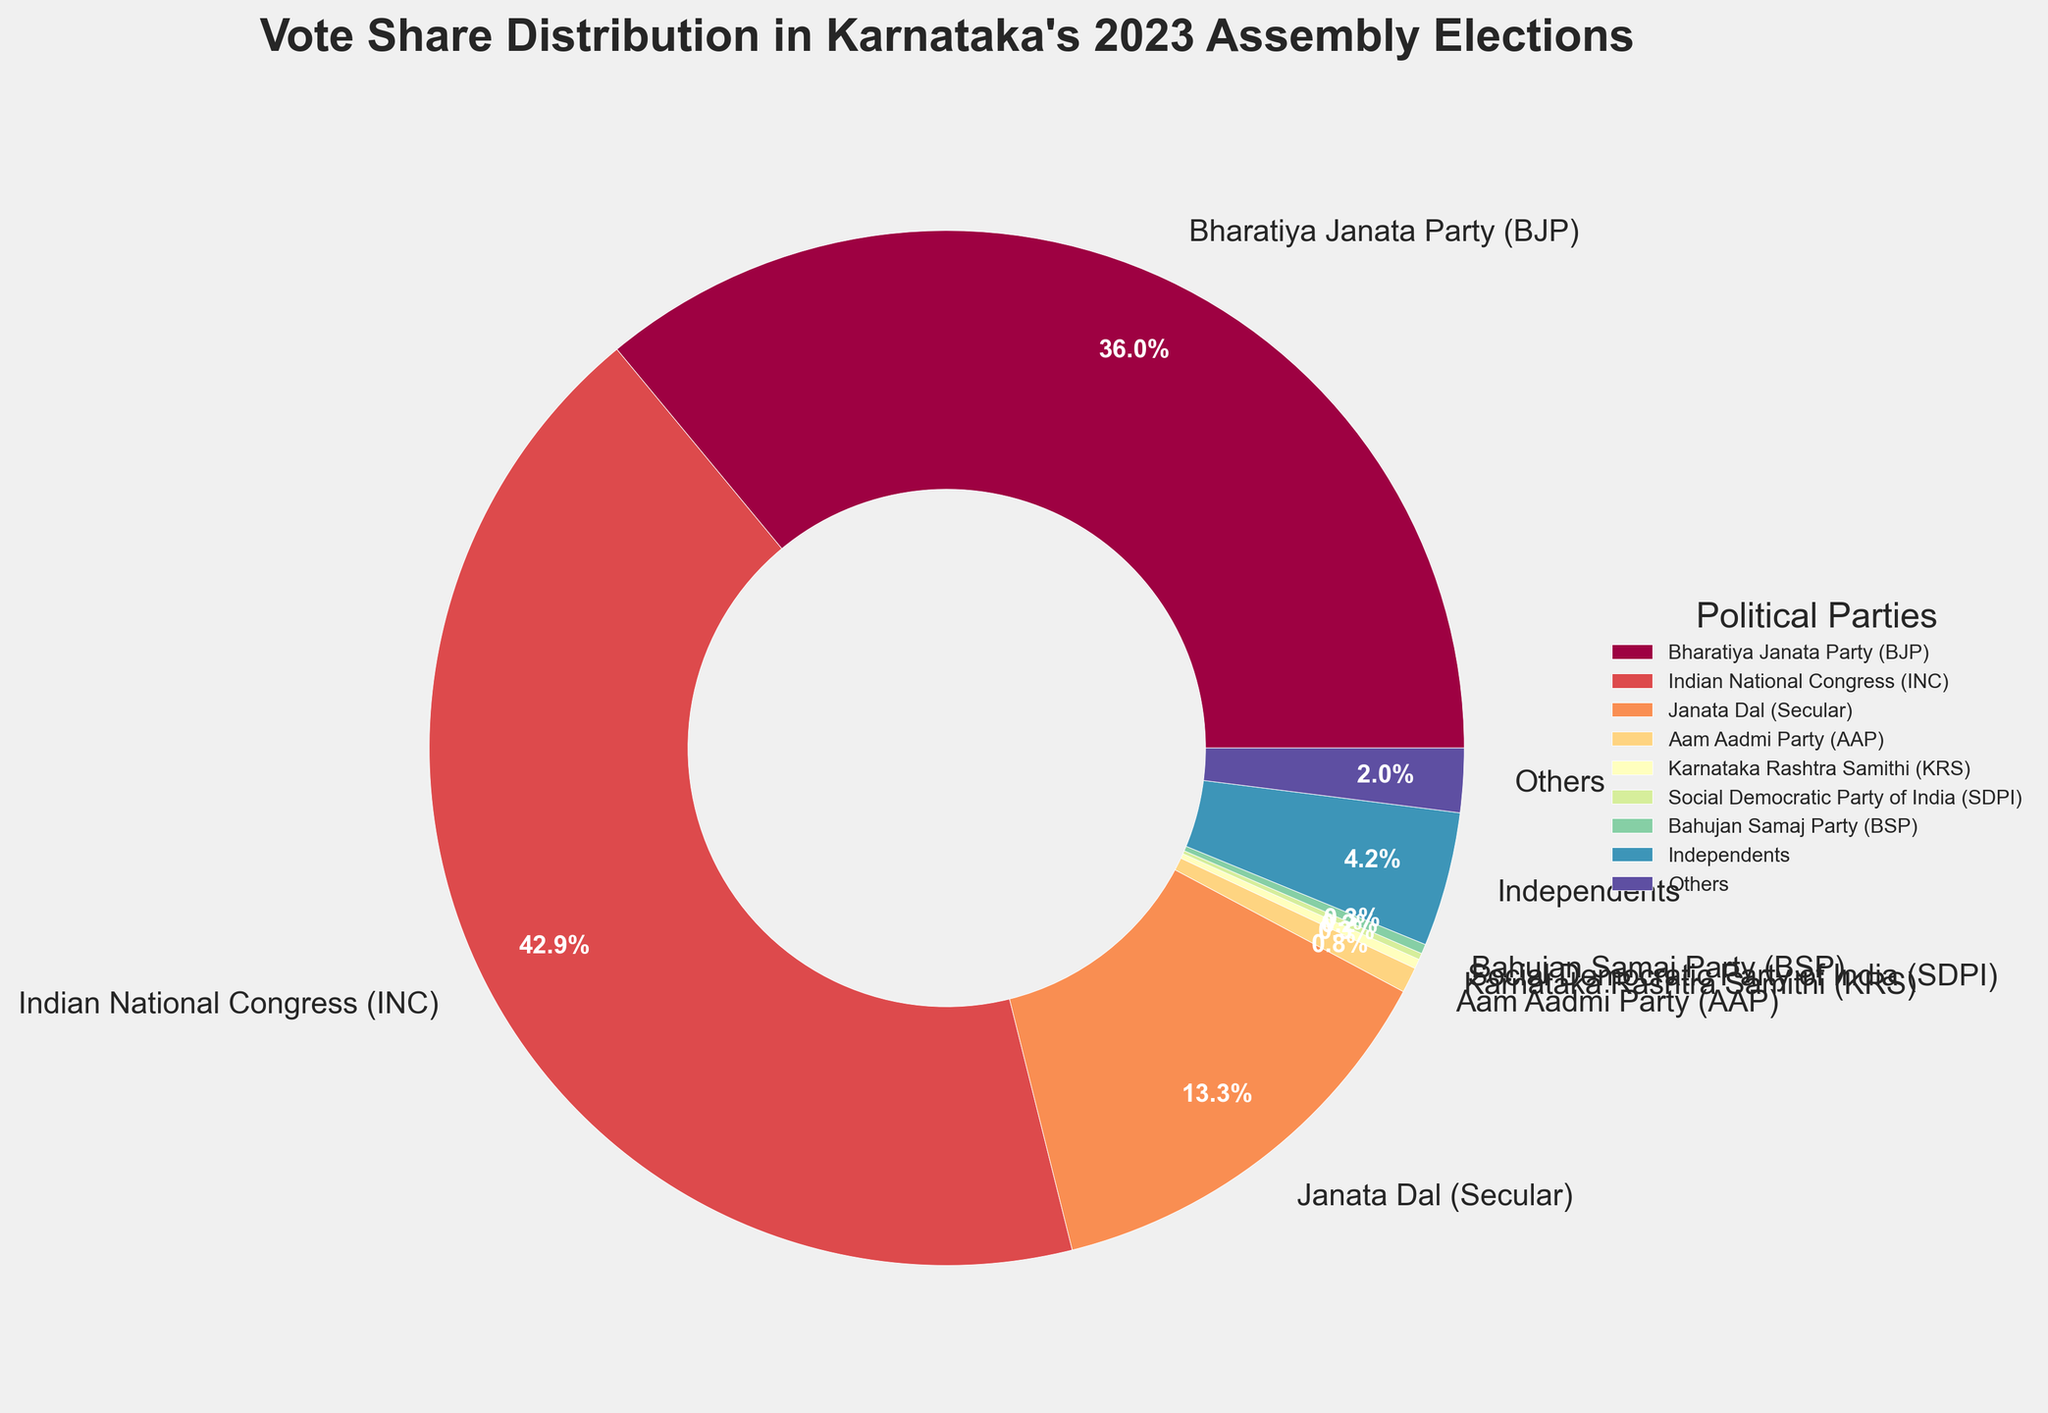What percentage of the vote share did the BJP and the INC combine for? The pie chart provides the vote shares for BJP and INC as 36.0% and 42.9% respectively. To find the combined percentage, simply add these two values together: 36.0 + 42.9 = 78.9%.
Answer: 78.9% Which party received a higher vote share, the Janata Dal (Secular) or the Independents? The pie chart shows Janata Dal (Secular) received 13.3% and Independents received 4.2%. Since 13.3% is greater than 4.2%, Janata Dal (Secular) received a higher vote share.
Answer: Janata Dal (Secular) What is the difference in vote share between the party with the largest share and the party with the smallest share? The largest vote share is held by INC at 42.9% and the smallest by SDPI at 0.2%. The difference between them is calculated as 42.9 - 0.2 = 42.7%.
Answer: 42.7% Which parties received less than 1% of the vote share? The pie chart indicates that Aam Aadmi Party (0.8%), Karnataka Rashtra Samithi (0.3%), Social Democratic Party of India (0.2%), and Bahujan Samaj Party (0.3%) each received less than 1% of the vote share.
Answer: AAP, KRS, SDPI, BSP What color represents the Indian National Congress (INC) in the pie chart? The pie chart uses a spectrum of colors, with each party represented by a unique color. The specific color for INC can be seen directly on the chart, commonly depicted in a noticeable shade, but without viewing the chart, the exact description isn't possible.
Answer: [Exact color from the chart] What is the total vote share covered by "Others" and Independents combined? The pie chart provides the vote shares for Others at 2.0% and Independents at 4.2%. Adding these two values together gives 2.0 + 4.2 = 6.2%.
Answer: 6.2% Between the Aam Aadmi Party (AAP) and Karnataka Rashtra Samithi (KRS), which party has a higher vote share and by how much? The pie chart shows that AAP has a vote share of 0.8% and KRS has 0.3%. The difference is calculated as 0.8 - 0.3 = 0.5%. AAP has a higher vote share by 0.5%.
Answer: AAP by 0.5% 